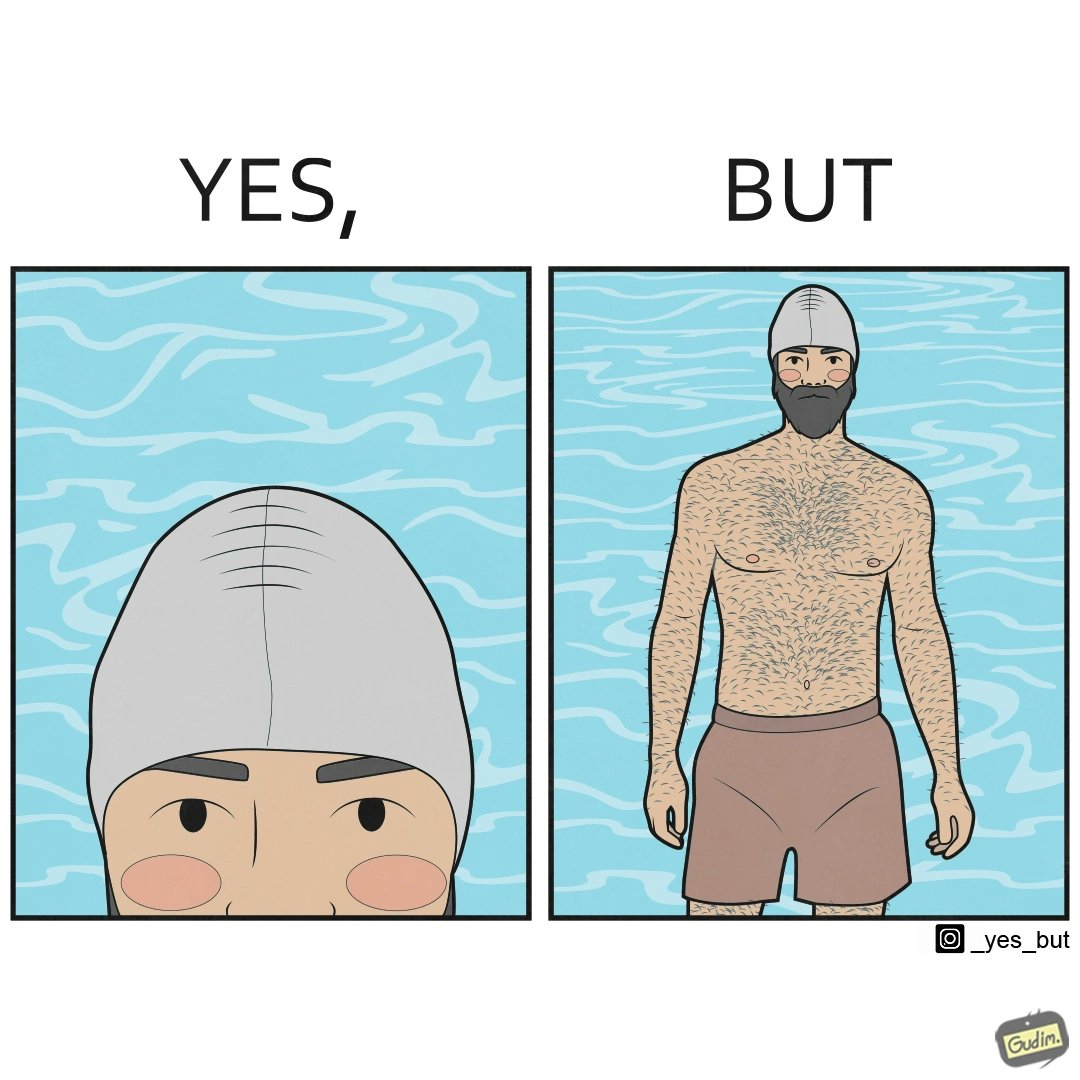What is shown in this image? The man is wearing a swimming cap to protect his head's hair but on the other side he is not concerned over the hair all over his body and is nowhere covering them 